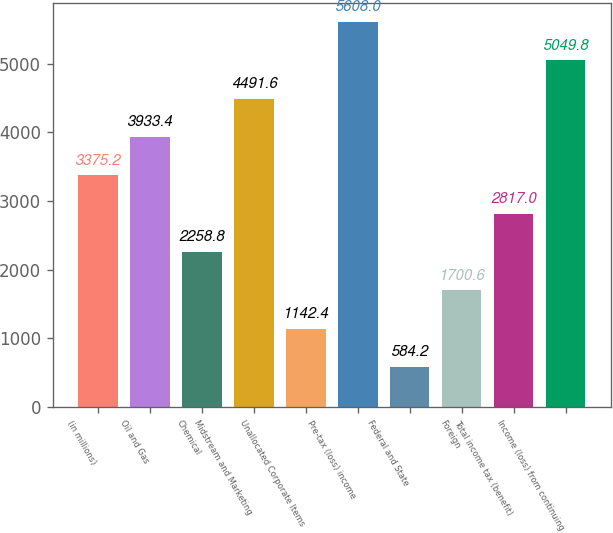Convert chart to OTSL. <chart><loc_0><loc_0><loc_500><loc_500><bar_chart><fcel>(in millions)<fcel>Oil and Gas<fcel>Chemical<fcel>Midstream and Marketing<fcel>Unallocated Corporate Items<fcel>Pre-tax (loss) income<fcel>Federal and State<fcel>Foreign<fcel>Total income tax (benefit)<fcel>Income (loss) from continuing<nl><fcel>3375.2<fcel>3933.4<fcel>2258.8<fcel>4491.6<fcel>1142.4<fcel>5608<fcel>584.2<fcel>1700.6<fcel>2817<fcel>5049.8<nl></chart> 